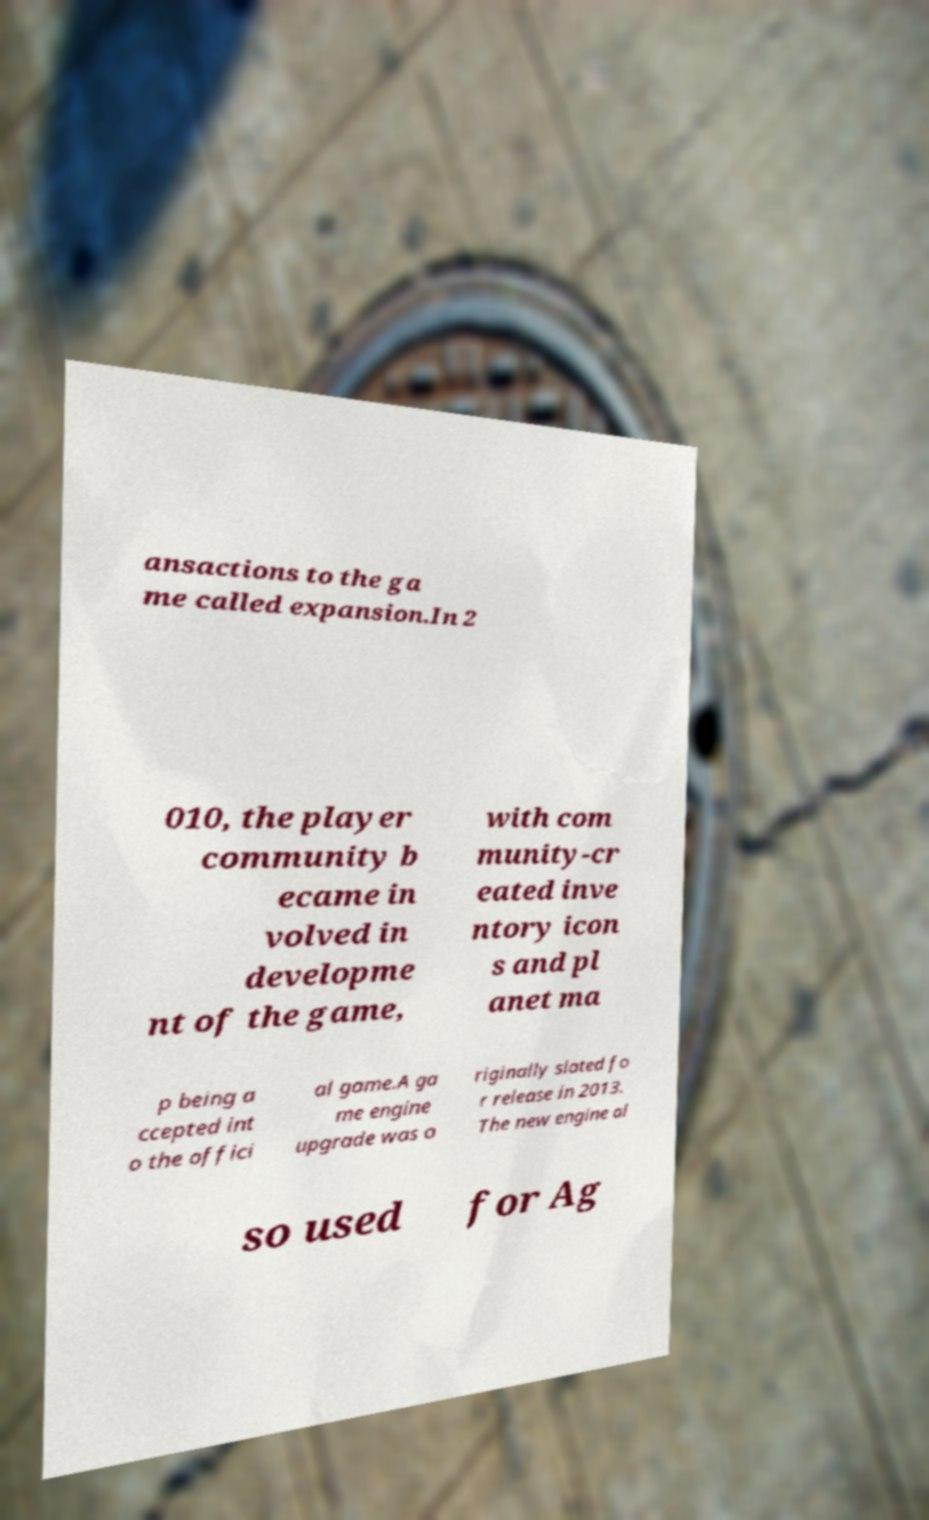There's text embedded in this image that I need extracted. Can you transcribe it verbatim? ansactions to the ga me called expansion.In 2 010, the player community b ecame in volved in developme nt of the game, with com munity-cr eated inve ntory icon s and pl anet ma p being a ccepted int o the offici al game.A ga me engine upgrade was o riginally slated fo r release in 2013. The new engine al so used for Ag 